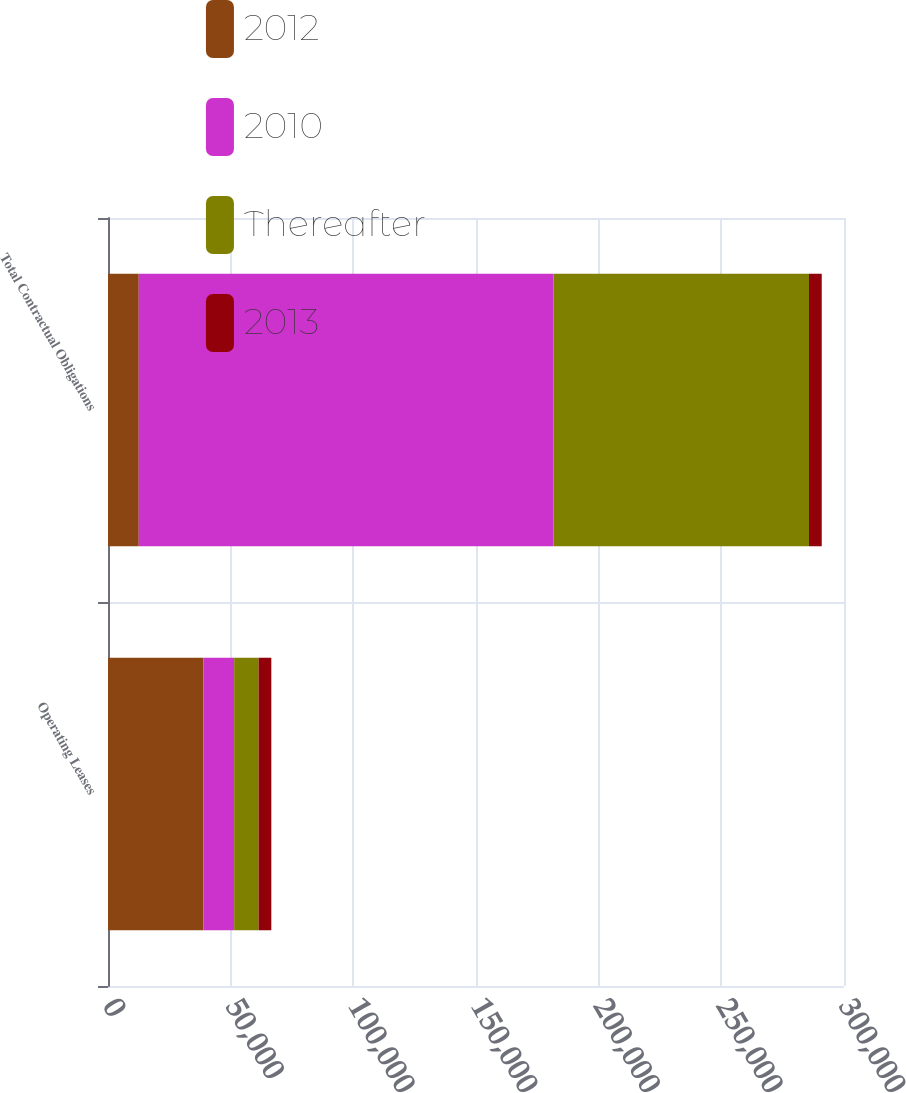Convert chart to OTSL. <chart><loc_0><loc_0><loc_500><loc_500><stacked_bar_chart><ecel><fcel>Operating Leases<fcel>Total Contractual Obligations<nl><fcel>2012<fcel>38886<fcel>12538<nl><fcel>2010<fcel>12538<fcel>169009<nl><fcel>Thereafter<fcel>9970<fcel>104183<nl><fcel>2013<fcel>5174<fcel>5194<nl></chart> 